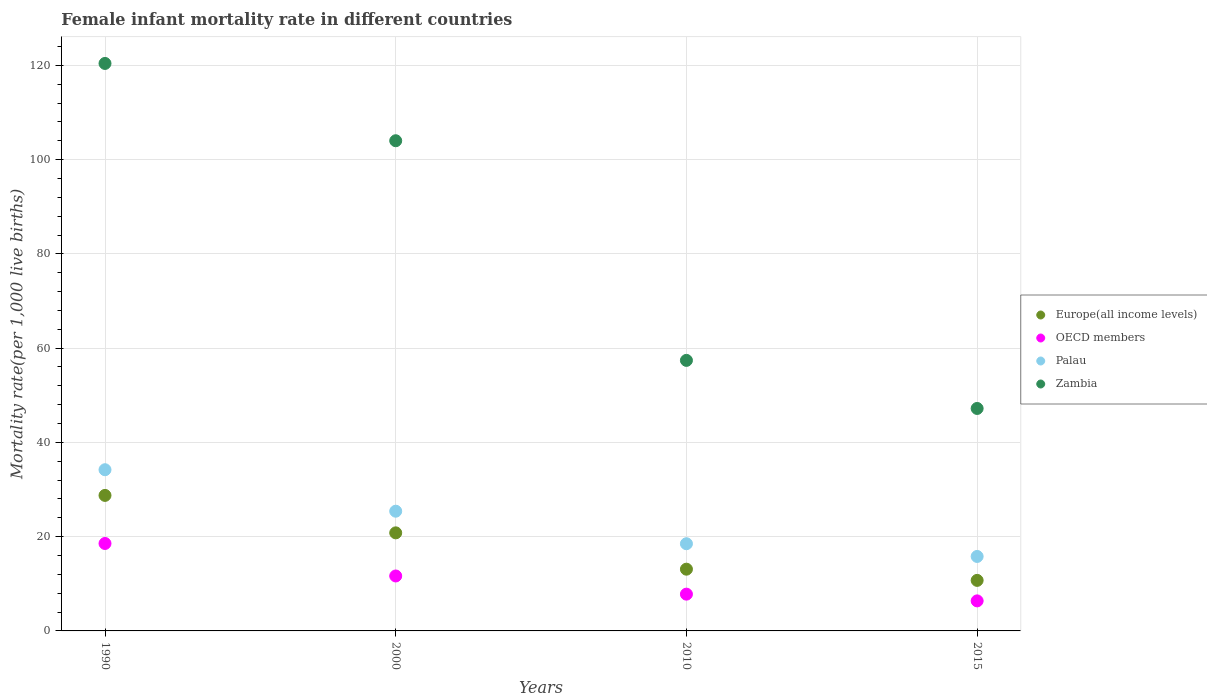Is the number of dotlines equal to the number of legend labels?
Your answer should be very brief. Yes. What is the female infant mortality rate in Europe(all income levels) in 2000?
Keep it short and to the point. 20.81. Across all years, what is the maximum female infant mortality rate in OECD members?
Your answer should be very brief. 18.55. Across all years, what is the minimum female infant mortality rate in Zambia?
Ensure brevity in your answer.  47.2. In which year was the female infant mortality rate in Palau minimum?
Provide a succinct answer. 2015. What is the total female infant mortality rate in Palau in the graph?
Offer a terse response. 93.9. What is the difference between the female infant mortality rate in Zambia in 1990 and that in 2000?
Provide a short and direct response. 16.4. What is the difference between the female infant mortality rate in Zambia in 1990 and the female infant mortality rate in Palau in 2010?
Make the answer very short. 101.9. What is the average female infant mortality rate in Zambia per year?
Your answer should be compact. 82.25. In the year 1990, what is the difference between the female infant mortality rate in Palau and female infant mortality rate in Zambia?
Your answer should be very brief. -86.2. In how many years, is the female infant mortality rate in Europe(all income levels) greater than 52?
Provide a short and direct response. 0. What is the ratio of the female infant mortality rate in OECD members in 2000 to that in 2015?
Provide a succinct answer. 1.83. Is the female infant mortality rate in OECD members in 2000 less than that in 2010?
Provide a succinct answer. No. Is the difference between the female infant mortality rate in Palau in 2000 and 2010 greater than the difference between the female infant mortality rate in Zambia in 2000 and 2010?
Offer a very short reply. No. What is the difference between the highest and the second highest female infant mortality rate in OECD members?
Provide a succinct answer. 6.89. What is the difference between the highest and the lowest female infant mortality rate in Europe(all income levels)?
Your response must be concise. 18.03. In how many years, is the female infant mortality rate in Zambia greater than the average female infant mortality rate in Zambia taken over all years?
Ensure brevity in your answer.  2. Is the sum of the female infant mortality rate in Europe(all income levels) in 2010 and 2015 greater than the maximum female infant mortality rate in Zambia across all years?
Offer a very short reply. No. Is it the case that in every year, the sum of the female infant mortality rate in Palau and female infant mortality rate in Zambia  is greater than the sum of female infant mortality rate in OECD members and female infant mortality rate in Europe(all income levels)?
Give a very brief answer. No. Does the female infant mortality rate in OECD members monotonically increase over the years?
Offer a very short reply. No. Is the female infant mortality rate in Zambia strictly less than the female infant mortality rate in Europe(all income levels) over the years?
Make the answer very short. No. How many dotlines are there?
Provide a short and direct response. 4. What is the difference between two consecutive major ticks on the Y-axis?
Provide a succinct answer. 20. Does the graph contain any zero values?
Make the answer very short. No. What is the title of the graph?
Your response must be concise. Female infant mortality rate in different countries. Does "Puerto Rico" appear as one of the legend labels in the graph?
Give a very brief answer. No. What is the label or title of the Y-axis?
Offer a terse response. Mortality rate(per 1,0 live births). What is the Mortality rate(per 1,000 live births) of Europe(all income levels) in 1990?
Provide a succinct answer. 28.75. What is the Mortality rate(per 1,000 live births) in OECD members in 1990?
Make the answer very short. 18.55. What is the Mortality rate(per 1,000 live births) of Palau in 1990?
Your response must be concise. 34.2. What is the Mortality rate(per 1,000 live births) of Zambia in 1990?
Provide a succinct answer. 120.4. What is the Mortality rate(per 1,000 live births) of Europe(all income levels) in 2000?
Your response must be concise. 20.81. What is the Mortality rate(per 1,000 live births) in OECD members in 2000?
Your answer should be compact. 11.66. What is the Mortality rate(per 1,000 live births) of Palau in 2000?
Make the answer very short. 25.4. What is the Mortality rate(per 1,000 live births) of Zambia in 2000?
Give a very brief answer. 104. What is the Mortality rate(per 1,000 live births) in Europe(all income levels) in 2010?
Offer a terse response. 13.1. What is the Mortality rate(per 1,000 live births) in OECD members in 2010?
Your answer should be compact. 7.8. What is the Mortality rate(per 1,000 live births) of Palau in 2010?
Keep it short and to the point. 18.5. What is the Mortality rate(per 1,000 live births) in Zambia in 2010?
Offer a very short reply. 57.4. What is the Mortality rate(per 1,000 live births) of Europe(all income levels) in 2015?
Give a very brief answer. 10.72. What is the Mortality rate(per 1,000 live births) in OECD members in 2015?
Keep it short and to the point. 6.37. What is the Mortality rate(per 1,000 live births) in Palau in 2015?
Give a very brief answer. 15.8. What is the Mortality rate(per 1,000 live births) of Zambia in 2015?
Your answer should be very brief. 47.2. Across all years, what is the maximum Mortality rate(per 1,000 live births) in Europe(all income levels)?
Ensure brevity in your answer.  28.75. Across all years, what is the maximum Mortality rate(per 1,000 live births) in OECD members?
Keep it short and to the point. 18.55. Across all years, what is the maximum Mortality rate(per 1,000 live births) in Palau?
Your response must be concise. 34.2. Across all years, what is the maximum Mortality rate(per 1,000 live births) of Zambia?
Your answer should be very brief. 120.4. Across all years, what is the minimum Mortality rate(per 1,000 live births) in Europe(all income levels)?
Keep it short and to the point. 10.72. Across all years, what is the minimum Mortality rate(per 1,000 live births) of OECD members?
Offer a very short reply. 6.37. Across all years, what is the minimum Mortality rate(per 1,000 live births) in Zambia?
Ensure brevity in your answer.  47.2. What is the total Mortality rate(per 1,000 live births) in Europe(all income levels) in the graph?
Ensure brevity in your answer.  73.38. What is the total Mortality rate(per 1,000 live births) in OECD members in the graph?
Your response must be concise. 44.38. What is the total Mortality rate(per 1,000 live births) in Palau in the graph?
Offer a very short reply. 93.9. What is the total Mortality rate(per 1,000 live births) of Zambia in the graph?
Give a very brief answer. 329. What is the difference between the Mortality rate(per 1,000 live births) of Europe(all income levels) in 1990 and that in 2000?
Provide a succinct answer. 7.95. What is the difference between the Mortality rate(per 1,000 live births) of OECD members in 1990 and that in 2000?
Ensure brevity in your answer.  6.89. What is the difference between the Mortality rate(per 1,000 live births) of Europe(all income levels) in 1990 and that in 2010?
Ensure brevity in your answer.  15.65. What is the difference between the Mortality rate(per 1,000 live births) of OECD members in 1990 and that in 2010?
Provide a succinct answer. 10.75. What is the difference between the Mortality rate(per 1,000 live births) in Zambia in 1990 and that in 2010?
Your response must be concise. 63. What is the difference between the Mortality rate(per 1,000 live births) in Europe(all income levels) in 1990 and that in 2015?
Your answer should be very brief. 18.03. What is the difference between the Mortality rate(per 1,000 live births) in OECD members in 1990 and that in 2015?
Your answer should be very brief. 12.18. What is the difference between the Mortality rate(per 1,000 live births) in Zambia in 1990 and that in 2015?
Offer a terse response. 73.2. What is the difference between the Mortality rate(per 1,000 live births) of Europe(all income levels) in 2000 and that in 2010?
Make the answer very short. 7.71. What is the difference between the Mortality rate(per 1,000 live births) in OECD members in 2000 and that in 2010?
Your answer should be very brief. 3.86. What is the difference between the Mortality rate(per 1,000 live births) in Zambia in 2000 and that in 2010?
Offer a very short reply. 46.6. What is the difference between the Mortality rate(per 1,000 live births) in Europe(all income levels) in 2000 and that in 2015?
Offer a very short reply. 10.08. What is the difference between the Mortality rate(per 1,000 live births) of OECD members in 2000 and that in 2015?
Ensure brevity in your answer.  5.28. What is the difference between the Mortality rate(per 1,000 live births) in Palau in 2000 and that in 2015?
Your response must be concise. 9.6. What is the difference between the Mortality rate(per 1,000 live births) of Zambia in 2000 and that in 2015?
Provide a succinct answer. 56.8. What is the difference between the Mortality rate(per 1,000 live births) in Europe(all income levels) in 2010 and that in 2015?
Offer a very short reply. 2.38. What is the difference between the Mortality rate(per 1,000 live births) of OECD members in 2010 and that in 2015?
Offer a terse response. 1.43. What is the difference between the Mortality rate(per 1,000 live births) in Europe(all income levels) in 1990 and the Mortality rate(per 1,000 live births) in OECD members in 2000?
Your answer should be compact. 17.09. What is the difference between the Mortality rate(per 1,000 live births) of Europe(all income levels) in 1990 and the Mortality rate(per 1,000 live births) of Palau in 2000?
Ensure brevity in your answer.  3.35. What is the difference between the Mortality rate(per 1,000 live births) in Europe(all income levels) in 1990 and the Mortality rate(per 1,000 live births) in Zambia in 2000?
Offer a very short reply. -75.25. What is the difference between the Mortality rate(per 1,000 live births) of OECD members in 1990 and the Mortality rate(per 1,000 live births) of Palau in 2000?
Your answer should be compact. -6.85. What is the difference between the Mortality rate(per 1,000 live births) in OECD members in 1990 and the Mortality rate(per 1,000 live births) in Zambia in 2000?
Give a very brief answer. -85.45. What is the difference between the Mortality rate(per 1,000 live births) of Palau in 1990 and the Mortality rate(per 1,000 live births) of Zambia in 2000?
Provide a succinct answer. -69.8. What is the difference between the Mortality rate(per 1,000 live births) in Europe(all income levels) in 1990 and the Mortality rate(per 1,000 live births) in OECD members in 2010?
Offer a terse response. 20.95. What is the difference between the Mortality rate(per 1,000 live births) in Europe(all income levels) in 1990 and the Mortality rate(per 1,000 live births) in Palau in 2010?
Your answer should be compact. 10.25. What is the difference between the Mortality rate(per 1,000 live births) of Europe(all income levels) in 1990 and the Mortality rate(per 1,000 live births) of Zambia in 2010?
Ensure brevity in your answer.  -28.65. What is the difference between the Mortality rate(per 1,000 live births) in OECD members in 1990 and the Mortality rate(per 1,000 live births) in Palau in 2010?
Make the answer very short. 0.05. What is the difference between the Mortality rate(per 1,000 live births) in OECD members in 1990 and the Mortality rate(per 1,000 live births) in Zambia in 2010?
Keep it short and to the point. -38.85. What is the difference between the Mortality rate(per 1,000 live births) of Palau in 1990 and the Mortality rate(per 1,000 live births) of Zambia in 2010?
Make the answer very short. -23.2. What is the difference between the Mortality rate(per 1,000 live births) in Europe(all income levels) in 1990 and the Mortality rate(per 1,000 live births) in OECD members in 2015?
Provide a succinct answer. 22.38. What is the difference between the Mortality rate(per 1,000 live births) of Europe(all income levels) in 1990 and the Mortality rate(per 1,000 live births) of Palau in 2015?
Your answer should be compact. 12.95. What is the difference between the Mortality rate(per 1,000 live births) of Europe(all income levels) in 1990 and the Mortality rate(per 1,000 live births) of Zambia in 2015?
Provide a short and direct response. -18.45. What is the difference between the Mortality rate(per 1,000 live births) in OECD members in 1990 and the Mortality rate(per 1,000 live births) in Palau in 2015?
Provide a short and direct response. 2.75. What is the difference between the Mortality rate(per 1,000 live births) in OECD members in 1990 and the Mortality rate(per 1,000 live births) in Zambia in 2015?
Offer a very short reply. -28.65. What is the difference between the Mortality rate(per 1,000 live births) in Palau in 1990 and the Mortality rate(per 1,000 live births) in Zambia in 2015?
Offer a terse response. -13. What is the difference between the Mortality rate(per 1,000 live births) in Europe(all income levels) in 2000 and the Mortality rate(per 1,000 live births) in OECD members in 2010?
Offer a very short reply. 13.01. What is the difference between the Mortality rate(per 1,000 live births) in Europe(all income levels) in 2000 and the Mortality rate(per 1,000 live births) in Palau in 2010?
Provide a short and direct response. 2.31. What is the difference between the Mortality rate(per 1,000 live births) in Europe(all income levels) in 2000 and the Mortality rate(per 1,000 live births) in Zambia in 2010?
Make the answer very short. -36.59. What is the difference between the Mortality rate(per 1,000 live births) in OECD members in 2000 and the Mortality rate(per 1,000 live births) in Palau in 2010?
Offer a very short reply. -6.84. What is the difference between the Mortality rate(per 1,000 live births) in OECD members in 2000 and the Mortality rate(per 1,000 live births) in Zambia in 2010?
Give a very brief answer. -45.74. What is the difference between the Mortality rate(per 1,000 live births) in Palau in 2000 and the Mortality rate(per 1,000 live births) in Zambia in 2010?
Make the answer very short. -32. What is the difference between the Mortality rate(per 1,000 live births) in Europe(all income levels) in 2000 and the Mortality rate(per 1,000 live births) in OECD members in 2015?
Provide a short and direct response. 14.43. What is the difference between the Mortality rate(per 1,000 live births) in Europe(all income levels) in 2000 and the Mortality rate(per 1,000 live births) in Palau in 2015?
Your response must be concise. 5.01. What is the difference between the Mortality rate(per 1,000 live births) of Europe(all income levels) in 2000 and the Mortality rate(per 1,000 live births) of Zambia in 2015?
Provide a succinct answer. -26.39. What is the difference between the Mortality rate(per 1,000 live births) of OECD members in 2000 and the Mortality rate(per 1,000 live births) of Palau in 2015?
Offer a very short reply. -4.14. What is the difference between the Mortality rate(per 1,000 live births) of OECD members in 2000 and the Mortality rate(per 1,000 live births) of Zambia in 2015?
Ensure brevity in your answer.  -35.54. What is the difference between the Mortality rate(per 1,000 live births) in Palau in 2000 and the Mortality rate(per 1,000 live births) in Zambia in 2015?
Provide a succinct answer. -21.8. What is the difference between the Mortality rate(per 1,000 live births) of Europe(all income levels) in 2010 and the Mortality rate(per 1,000 live births) of OECD members in 2015?
Your answer should be compact. 6.73. What is the difference between the Mortality rate(per 1,000 live births) in Europe(all income levels) in 2010 and the Mortality rate(per 1,000 live births) in Palau in 2015?
Provide a short and direct response. -2.7. What is the difference between the Mortality rate(per 1,000 live births) in Europe(all income levels) in 2010 and the Mortality rate(per 1,000 live births) in Zambia in 2015?
Ensure brevity in your answer.  -34.1. What is the difference between the Mortality rate(per 1,000 live births) of OECD members in 2010 and the Mortality rate(per 1,000 live births) of Palau in 2015?
Keep it short and to the point. -8. What is the difference between the Mortality rate(per 1,000 live births) of OECD members in 2010 and the Mortality rate(per 1,000 live births) of Zambia in 2015?
Give a very brief answer. -39.4. What is the difference between the Mortality rate(per 1,000 live births) in Palau in 2010 and the Mortality rate(per 1,000 live births) in Zambia in 2015?
Provide a succinct answer. -28.7. What is the average Mortality rate(per 1,000 live births) of Europe(all income levels) per year?
Give a very brief answer. 18.35. What is the average Mortality rate(per 1,000 live births) of OECD members per year?
Keep it short and to the point. 11.1. What is the average Mortality rate(per 1,000 live births) of Palau per year?
Ensure brevity in your answer.  23.48. What is the average Mortality rate(per 1,000 live births) in Zambia per year?
Offer a terse response. 82.25. In the year 1990, what is the difference between the Mortality rate(per 1,000 live births) in Europe(all income levels) and Mortality rate(per 1,000 live births) in OECD members?
Keep it short and to the point. 10.2. In the year 1990, what is the difference between the Mortality rate(per 1,000 live births) of Europe(all income levels) and Mortality rate(per 1,000 live births) of Palau?
Your response must be concise. -5.45. In the year 1990, what is the difference between the Mortality rate(per 1,000 live births) in Europe(all income levels) and Mortality rate(per 1,000 live births) in Zambia?
Keep it short and to the point. -91.65. In the year 1990, what is the difference between the Mortality rate(per 1,000 live births) in OECD members and Mortality rate(per 1,000 live births) in Palau?
Make the answer very short. -15.65. In the year 1990, what is the difference between the Mortality rate(per 1,000 live births) in OECD members and Mortality rate(per 1,000 live births) in Zambia?
Offer a terse response. -101.85. In the year 1990, what is the difference between the Mortality rate(per 1,000 live births) of Palau and Mortality rate(per 1,000 live births) of Zambia?
Give a very brief answer. -86.2. In the year 2000, what is the difference between the Mortality rate(per 1,000 live births) of Europe(all income levels) and Mortality rate(per 1,000 live births) of OECD members?
Provide a succinct answer. 9.15. In the year 2000, what is the difference between the Mortality rate(per 1,000 live births) of Europe(all income levels) and Mortality rate(per 1,000 live births) of Palau?
Your answer should be very brief. -4.59. In the year 2000, what is the difference between the Mortality rate(per 1,000 live births) of Europe(all income levels) and Mortality rate(per 1,000 live births) of Zambia?
Your answer should be very brief. -83.19. In the year 2000, what is the difference between the Mortality rate(per 1,000 live births) of OECD members and Mortality rate(per 1,000 live births) of Palau?
Make the answer very short. -13.74. In the year 2000, what is the difference between the Mortality rate(per 1,000 live births) of OECD members and Mortality rate(per 1,000 live births) of Zambia?
Give a very brief answer. -92.34. In the year 2000, what is the difference between the Mortality rate(per 1,000 live births) in Palau and Mortality rate(per 1,000 live births) in Zambia?
Offer a very short reply. -78.6. In the year 2010, what is the difference between the Mortality rate(per 1,000 live births) of Europe(all income levels) and Mortality rate(per 1,000 live births) of OECD members?
Your answer should be compact. 5.3. In the year 2010, what is the difference between the Mortality rate(per 1,000 live births) of Europe(all income levels) and Mortality rate(per 1,000 live births) of Palau?
Ensure brevity in your answer.  -5.4. In the year 2010, what is the difference between the Mortality rate(per 1,000 live births) in Europe(all income levels) and Mortality rate(per 1,000 live births) in Zambia?
Keep it short and to the point. -44.3. In the year 2010, what is the difference between the Mortality rate(per 1,000 live births) in OECD members and Mortality rate(per 1,000 live births) in Palau?
Offer a very short reply. -10.7. In the year 2010, what is the difference between the Mortality rate(per 1,000 live births) of OECD members and Mortality rate(per 1,000 live births) of Zambia?
Your answer should be very brief. -49.6. In the year 2010, what is the difference between the Mortality rate(per 1,000 live births) of Palau and Mortality rate(per 1,000 live births) of Zambia?
Make the answer very short. -38.9. In the year 2015, what is the difference between the Mortality rate(per 1,000 live births) in Europe(all income levels) and Mortality rate(per 1,000 live births) in OECD members?
Your answer should be compact. 4.35. In the year 2015, what is the difference between the Mortality rate(per 1,000 live births) of Europe(all income levels) and Mortality rate(per 1,000 live births) of Palau?
Offer a very short reply. -5.08. In the year 2015, what is the difference between the Mortality rate(per 1,000 live births) in Europe(all income levels) and Mortality rate(per 1,000 live births) in Zambia?
Offer a very short reply. -36.48. In the year 2015, what is the difference between the Mortality rate(per 1,000 live births) of OECD members and Mortality rate(per 1,000 live births) of Palau?
Provide a succinct answer. -9.43. In the year 2015, what is the difference between the Mortality rate(per 1,000 live births) of OECD members and Mortality rate(per 1,000 live births) of Zambia?
Your answer should be very brief. -40.83. In the year 2015, what is the difference between the Mortality rate(per 1,000 live births) of Palau and Mortality rate(per 1,000 live births) of Zambia?
Ensure brevity in your answer.  -31.4. What is the ratio of the Mortality rate(per 1,000 live births) of Europe(all income levels) in 1990 to that in 2000?
Keep it short and to the point. 1.38. What is the ratio of the Mortality rate(per 1,000 live births) in OECD members in 1990 to that in 2000?
Keep it short and to the point. 1.59. What is the ratio of the Mortality rate(per 1,000 live births) in Palau in 1990 to that in 2000?
Keep it short and to the point. 1.35. What is the ratio of the Mortality rate(per 1,000 live births) in Zambia in 1990 to that in 2000?
Your response must be concise. 1.16. What is the ratio of the Mortality rate(per 1,000 live births) in Europe(all income levels) in 1990 to that in 2010?
Provide a succinct answer. 2.19. What is the ratio of the Mortality rate(per 1,000 live births) in OECD members in 1990 to that in 2010?
Your response must be concise. 2.38. What is the ratio of the Mortality rate(per 1,000 live births) of Palau in 1990 to that in 2010?
Offer a terse response. 1.85. What is the ratio of the Mortality rate(per 1,000 live births) of Zambia in 1990 to that in 2010?
Offer a terse response. 2.1. What is the ratio of the Mortality rate(per 1,000 live births) of Europe(all income levels) in 1990 to that in 2015?
Give a very brief answer. 2.68. What is the ratio of the Mortality rate(per 1,000 live births) in OECD members in 1990 to that in 2015?
Your answer should be very brief. 2.91. What is the ratio of the Mortality rate(per 1,000 live births) of Palau in 1990 to that in 2015?
Offer a terse response. 2.16. What is the ratio of the Mortality rate(per 1,000 live births) of Zambia in 1990 to that in 2015?
Make the answer very short. 2.55. What is the ratio of the Mortality rate(per 1,000 live births) of Europe(all income levels) in 2000 to that in 2010?
Make the answer very short. 1.59. What is the ratio of the Mortality rate(per 1,000 live births) in OECD members in 2000 to that in 2010?
Ensure brevity in your answer.  1.49. What is the ratio of the Mortality rate(per 1,000 live births) in Palau in 2000 to that in 2010?
Provide a short and direct response. 1.37. What is the ratio of the Mortality rate(per 1,000 live births) of Zambia in 2000 to that in 2010?
Offer a very short reply. 1.81. What is the ratio of the Mortality rate(per 1,000 live births) in Europe(all income levels) in 2000 to that in 2015?
Give a very brief answer. 1.94. What is the ratio of the Mortality rate(per 1,000 live births) in OECD members in 2000 to that in 2015?
Your answer should be compact. 1.83. What is the ratio of the Mortality rate(per 1,000 live births) of Palau in 2000 to that in 2015?
Your answer should be very brief. 1.61. What is the ratio of the Mortality rate(per 1,000 live births) of Zambia in 2000 to that in 2015?
Ensure brevity in your answer.  2.2. What is the ratio of the Mortality rate(per 1,000 live births) of Europe(all income levels) in 2010 to that in 2015?
Your response must be concise. 1.22. What is the ratio of the Mortality rate(per 1,000 live births) in OECD members in 2010 to that in 2015?
Offer a terse response. 1.22. What is the ratio of the Mortality rate(per 1,000 live births) of Palau in 2010 to that in 2015?
Give a very brief answer. 1.17. What is the ratio of the Mortality rate(per 1,000 live births) of Zambia in 2010 to that in 2015?
Keep it short and to the point. 1.22. What is the difference between the highest and the second highest Mortality rate(per 1,000 live births) of Europe(all income levels)?
Offer a terse response. 7.95. What is the difference between the highest and the second highest Mortality rate(per 1,000 live births) of OECD members?
Keep it short and to the point. 6.89. What is the difference between the highest and the lowest Mortality rate(per 1,000 live births) of Europe(all income levels)?
Your answer should be very brief. 18.03. What is the difference between the highest and the lowest Mortality rate(per 1,000 live births) in OECD members?
Keep it short and to the point. 12.18. What is the difference between the highest and the lowest Mortality rate(per 1,000 live births) in Zambia?
Provide a succinct answer. 73.2. 